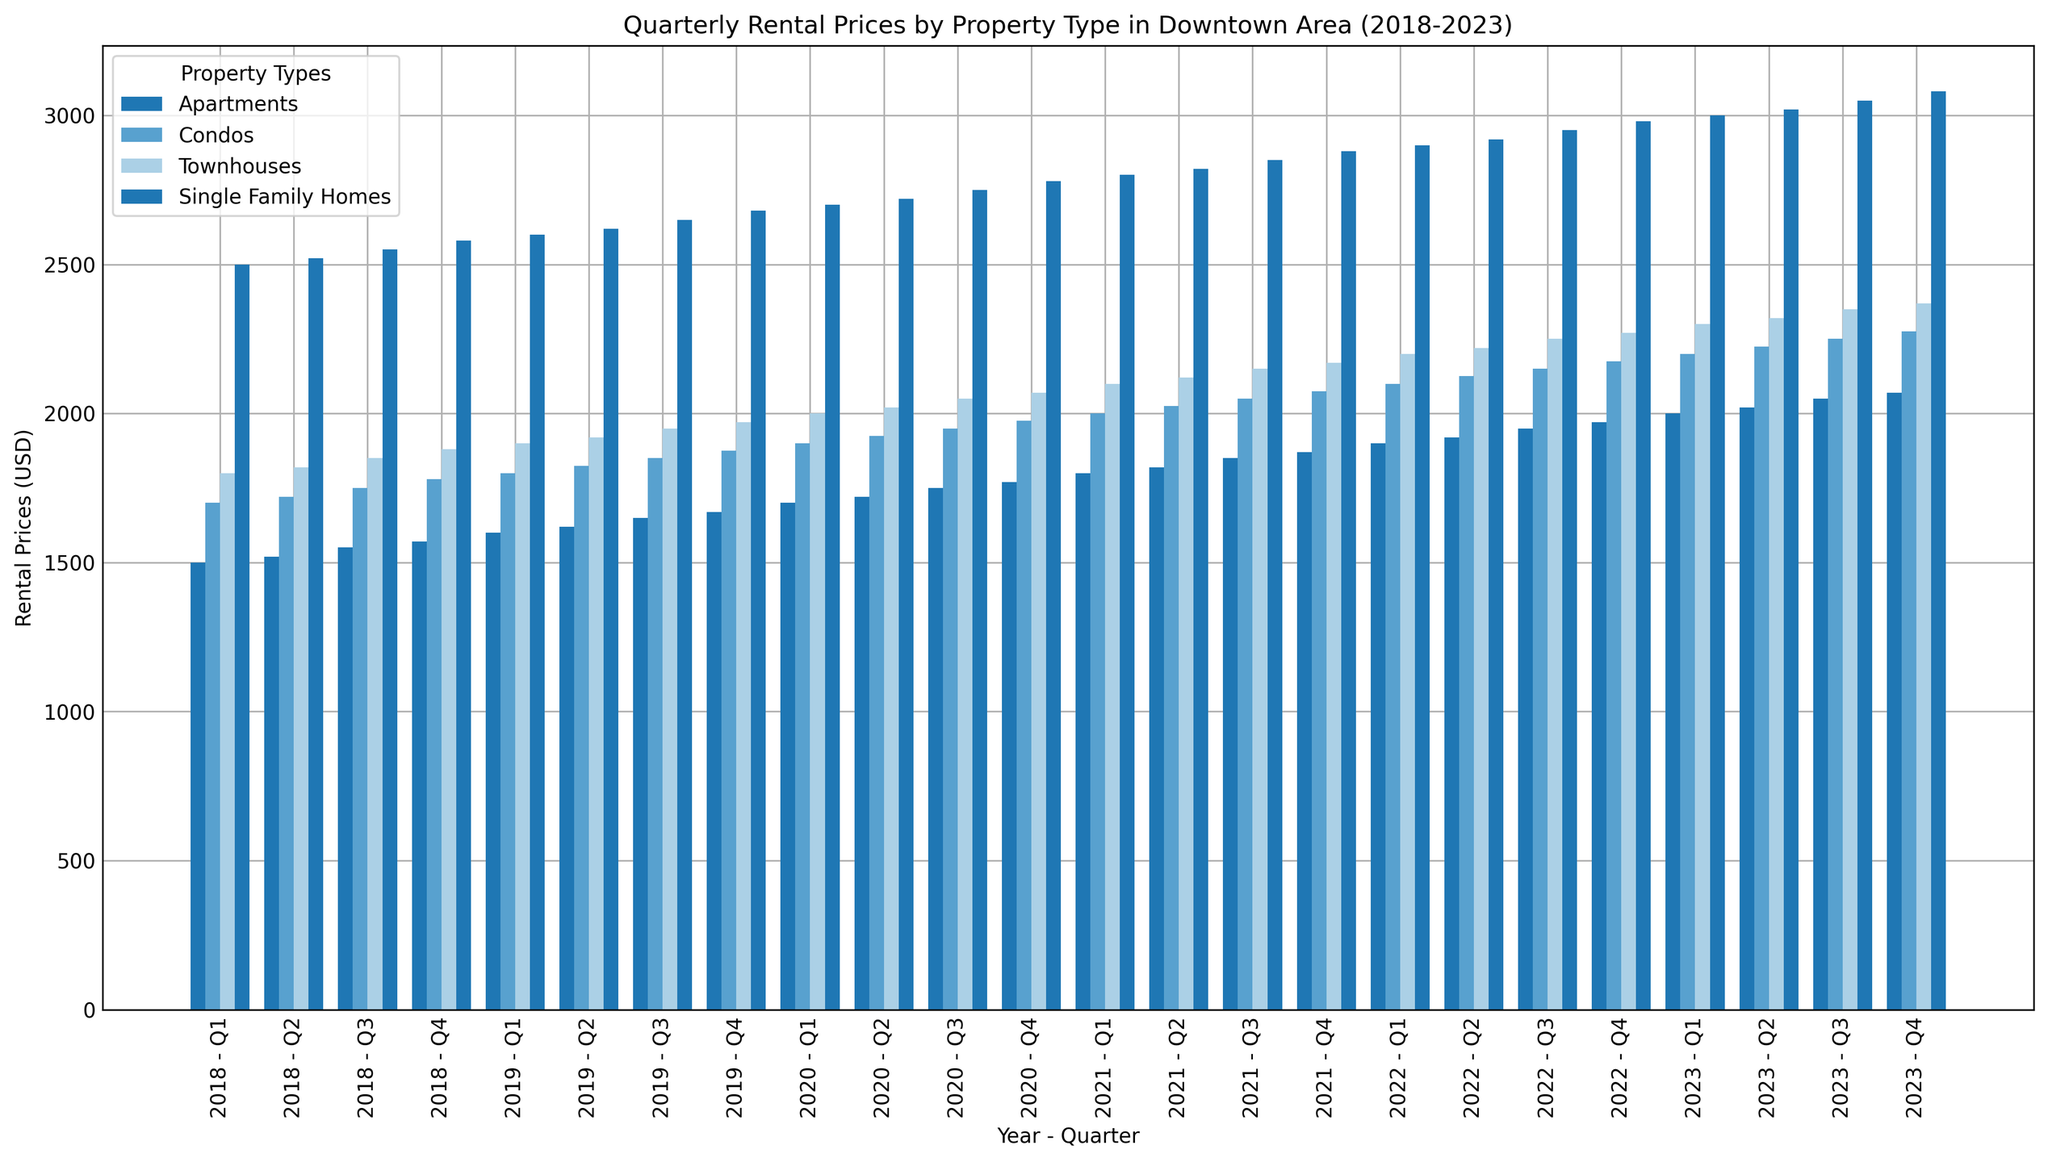What is the general trend in rental prices for apartments from 2018 to 2023? Rental prices for apartments show a steady upward trend from around $1500 in Q1 2018 to approximately $2070 in Q4 2023. This increase suggests a consistent rise in apartment rental prices over the five years.
Answer: Steady upward trend Which property type had the highest rental prices in Q3 2022? Looking at Q3 2022, the bars representing rental prices for all property types are visible. The bars are tallest for Single Family Homes, indicating that they had the highest rental prices in this quarter compared to apartments, condos, and townhouses.
Answer: Single Family Homes By how much did the rental prices for townhouses increase from Q1 2018 to Q4 2023? Rental prices for townhouses in Q1 2018 were $1800, while in Q4 2023, they were $2370. The increase can be calculated as $2370 - $1800 = $570.
Answer: $570 Comparing Q1 2020 and Q1 2023, which property type saw the greatest increase in rental prices? Looking at Q1 2020 and Q1 2023 for each property type, calculate the differences: 
- Apartments: $2000 - $1700 = $300
- Condos: $2200 - $1900 = $300
- Townhouses: $2300 - $2000 = $300
- Single Family Homes: $3000 - $2700 = $300
All property types show the same increase of $300 over this period.
Answer: All property types, each saw a $300 increase What is the pattern of rental prices for condos in 2021? In 2021, the rental prices for condos each quarter are: 
- Q1: $2000
- Q2: $2025
- Q3: $2050
- Q4: $2075
These prices show a gradual increase quarterly from $2000 in Q1 to $2075 in Q4.
Answer: Gradual quarterly increase What was the rental price for single-family homes in Q2 2019 compared to Q2 2020? In Q2 2019, the rental price for single-family homes was $2620. In Q2 2020, it increased to $2720. The difference is $2720 - $2620 = $100, indicating a $100 increase over the year.
Answer: $100 increase Which quarter saw the highest rental prices for apartments in 2023? Analyzing the rental prices for apartments in each quarter of 2023:
- Q1: $2000
- Q2: $2020
- Q3: $2050
- Q4: $2070
The highest rental price for apartments in 2023 is in Q4 with $2070.
Answer: Q4 2023 How did the average rental price for condos change from 2020 to 2022? Calculate the average prices for condos in 2020 and 2022:
- 2020: (1900 + 1925 + 1950 + 1975) / 4 = 1937.5
- 2022: (2100 + 2125 + 2150 + 2175) / 4 = 2137.5
The change in average rental prices is $2137.5 - $1937.5 = $200.
Answer: Increased by $200 